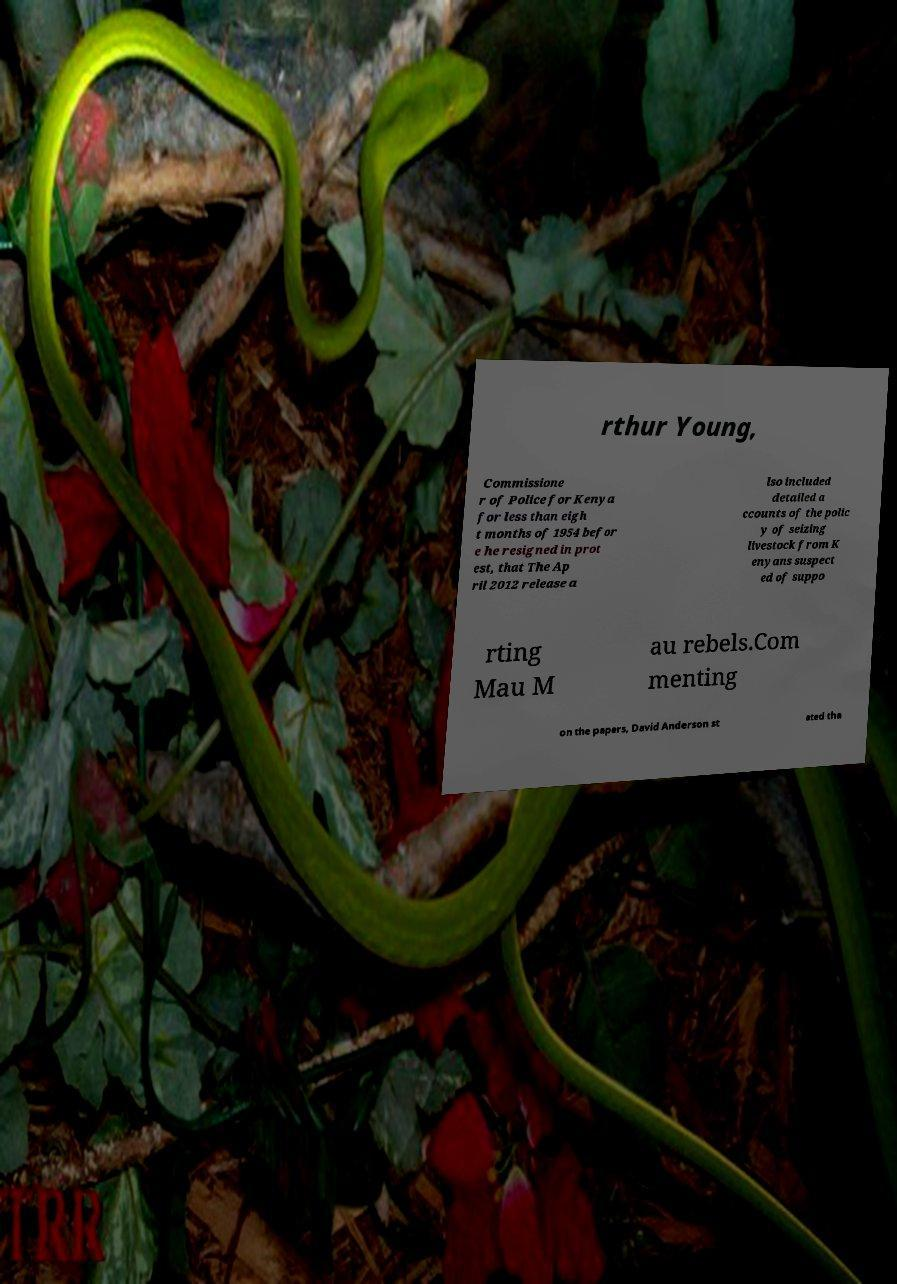Please identify and transcribe the text found in this image. rthur Young, Commissione r of Police for Kenya for less than eigh t months of 1954 befor e he resigned in prot est, that The Ap ril 2012 release a lso included detailed a ccounts of the polic y of seizing livestock from K enyans suspect ed of suppo rting Mau M au rebels.Com menting on the papers, David Anderson st ated tha 